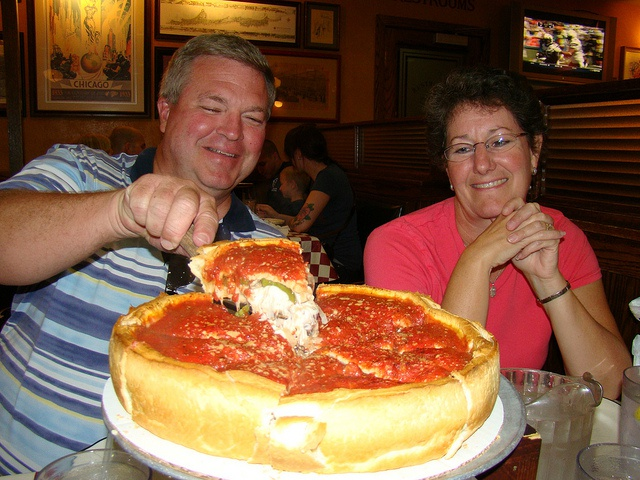Describe the objects in this image and their specific colors. I can see people in black, brown, gray, and darkgray tones, pizza in black, khaki, gold, red, and lightyellow tones, people in black and brown tones, pizza in black, beige, red, khaki, and orange tones, and tv in black, maroon, and olive tones in this image. 